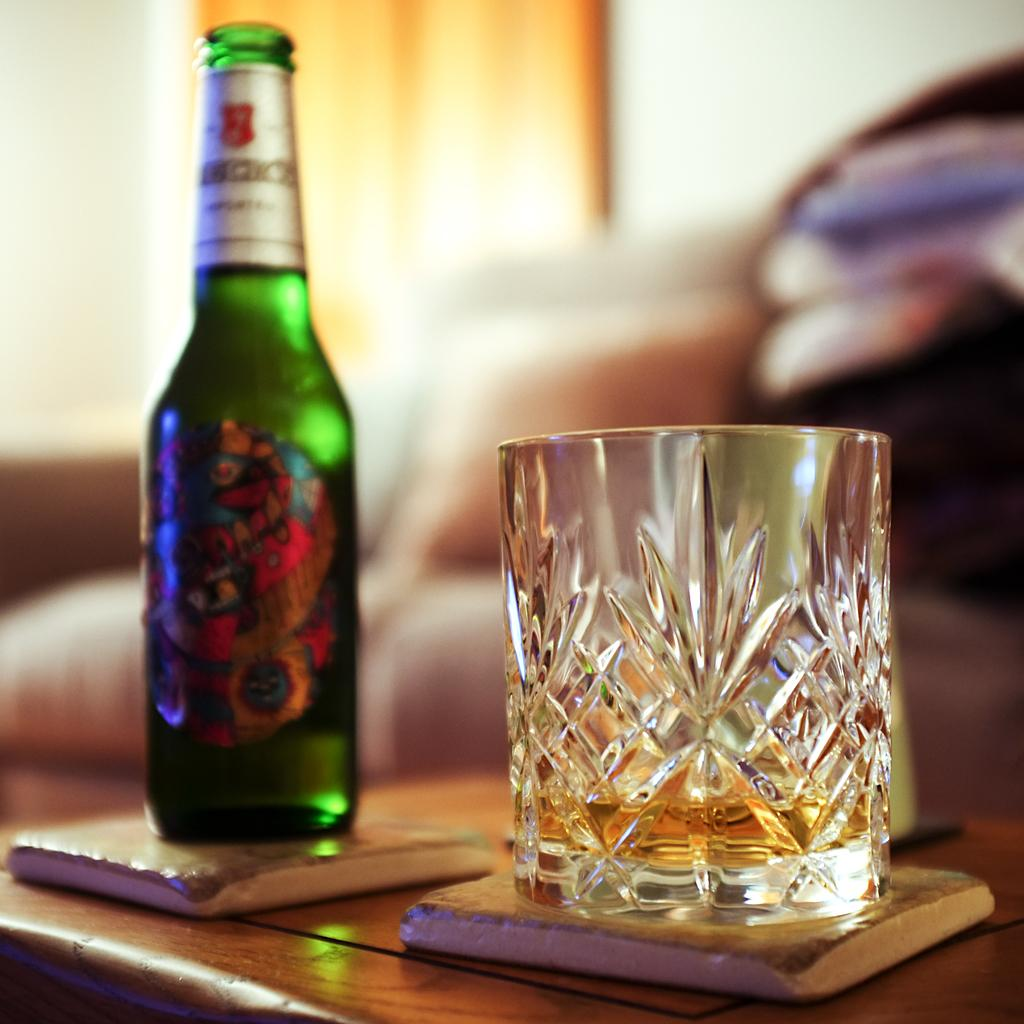Provide a one-sentence caption for the provided image. A glass of alcohol sitting next to an open bottle of beer with the word "And" visible on the label. 